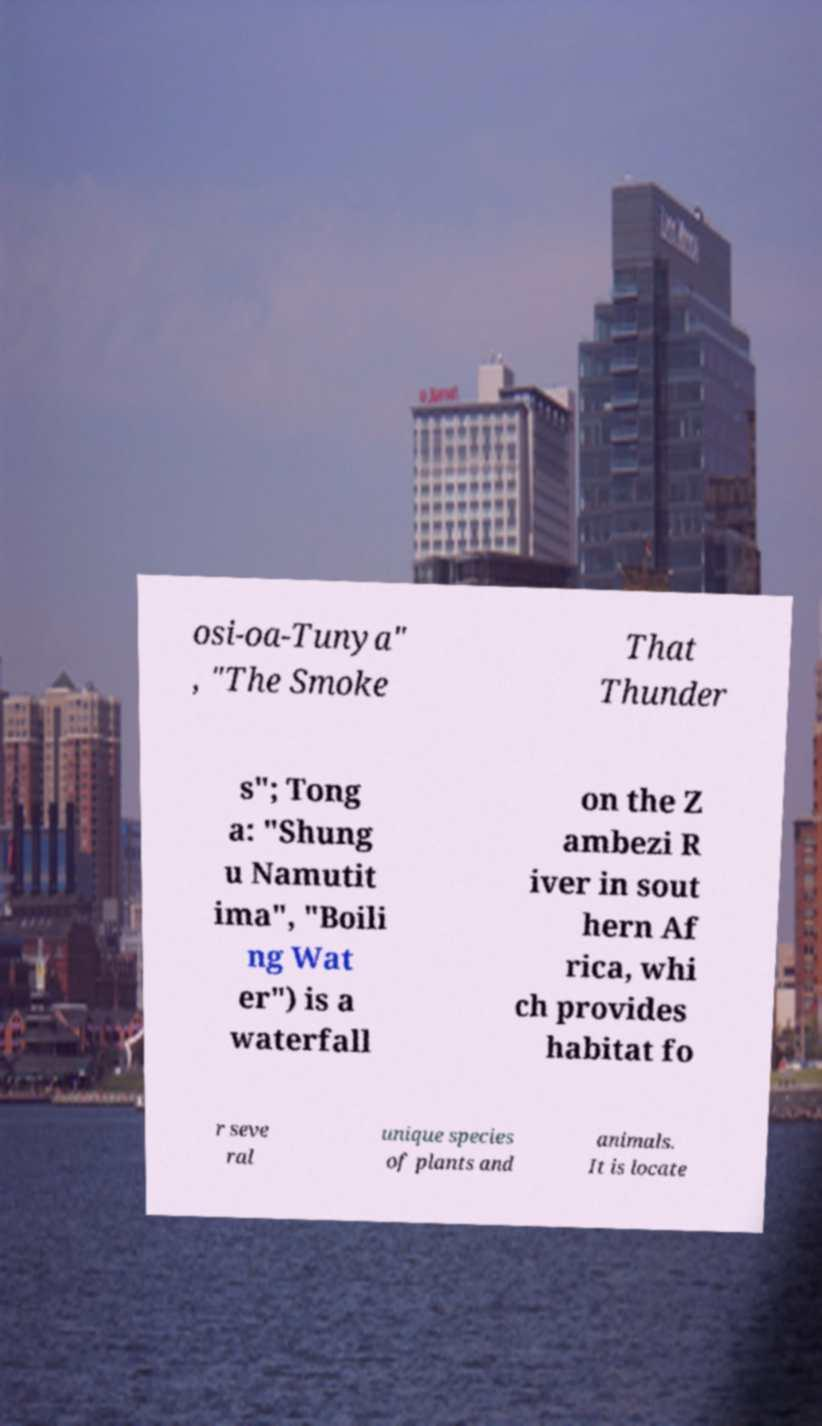Can you read and provide the text displayed in the image?This photo seems to have some interesting text. Can you extract and type it out for me? osi-oa-Tunya" , "The Smoke That Thunder s"; Tong a: "Shung u Namutit ima", "Boili ng Wat er") is a waterfall on the Z ambezi R iver in sout hern Af rica, whi ch provides habitat fo r seve ral unique species of plants and animals. It is locate 